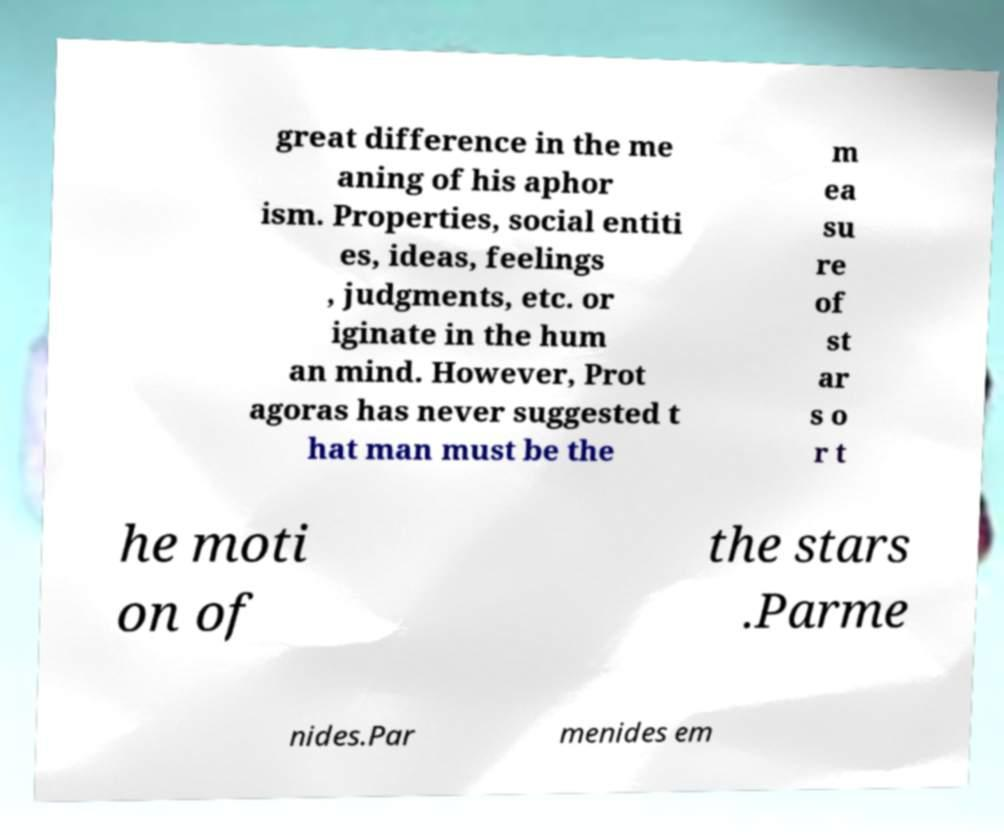Could you assist in decoding the text presented in this image and type it out clearly? great difference in the me aning of his aphor ism. Properties, social entiti es, ideas, feelings , judgments, etc. or iginate in the hum an mind. However, Prot agoras has never suggested t hat man must be the m ea su re of st ar s o r t he moti on of the stars .Parme nides.Par menides em 